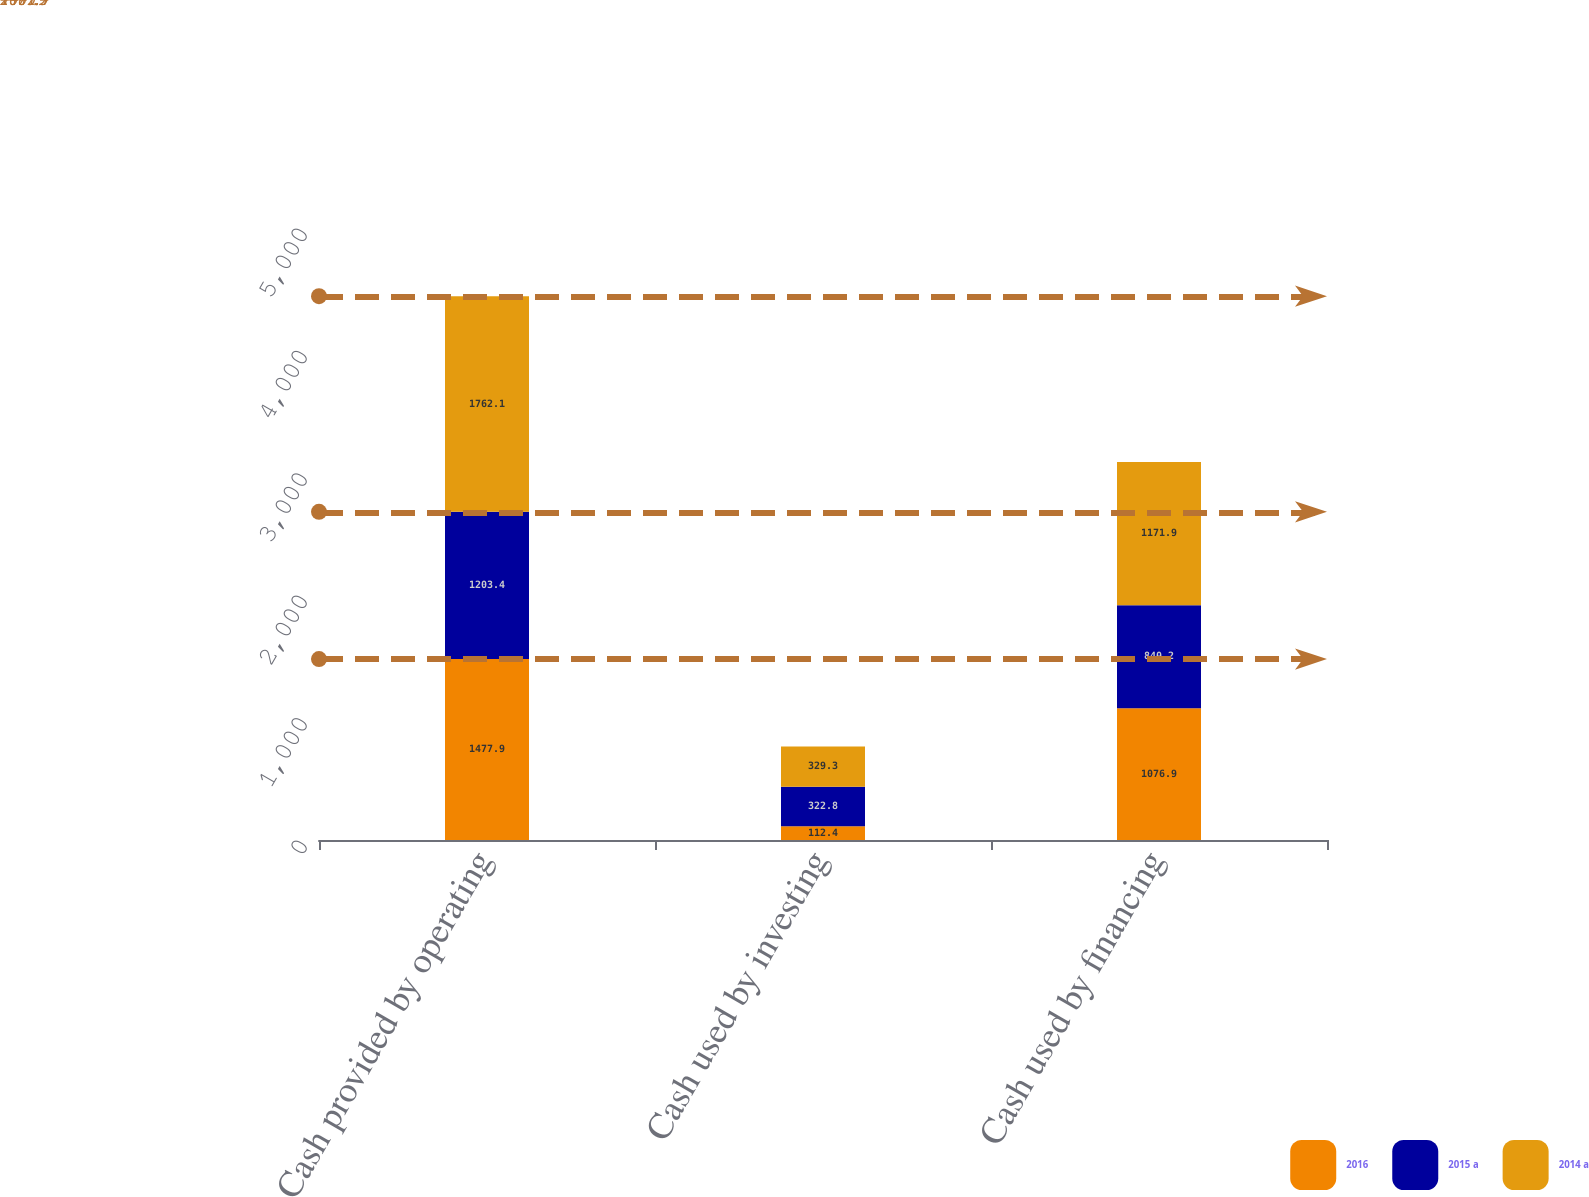Convert chart. <chart><loc_0><loc_0><loc_500><loc_500><stacked_bar_chart><ecel><fcel>Cash provided by operating<fcel>Cash used by investing<fcel>Cash used by financing<nl><fcel>2016<fcel>1477.9<fcel>112.4<fcel>1076.9<nl><fcel>2015 a<fcel>1203.4<fcel>322.8<fcel>840.2<nl><fcel>2014 a<fcel>1762.1<fcel>329.3<fcel>1171.9<nl></chart> 